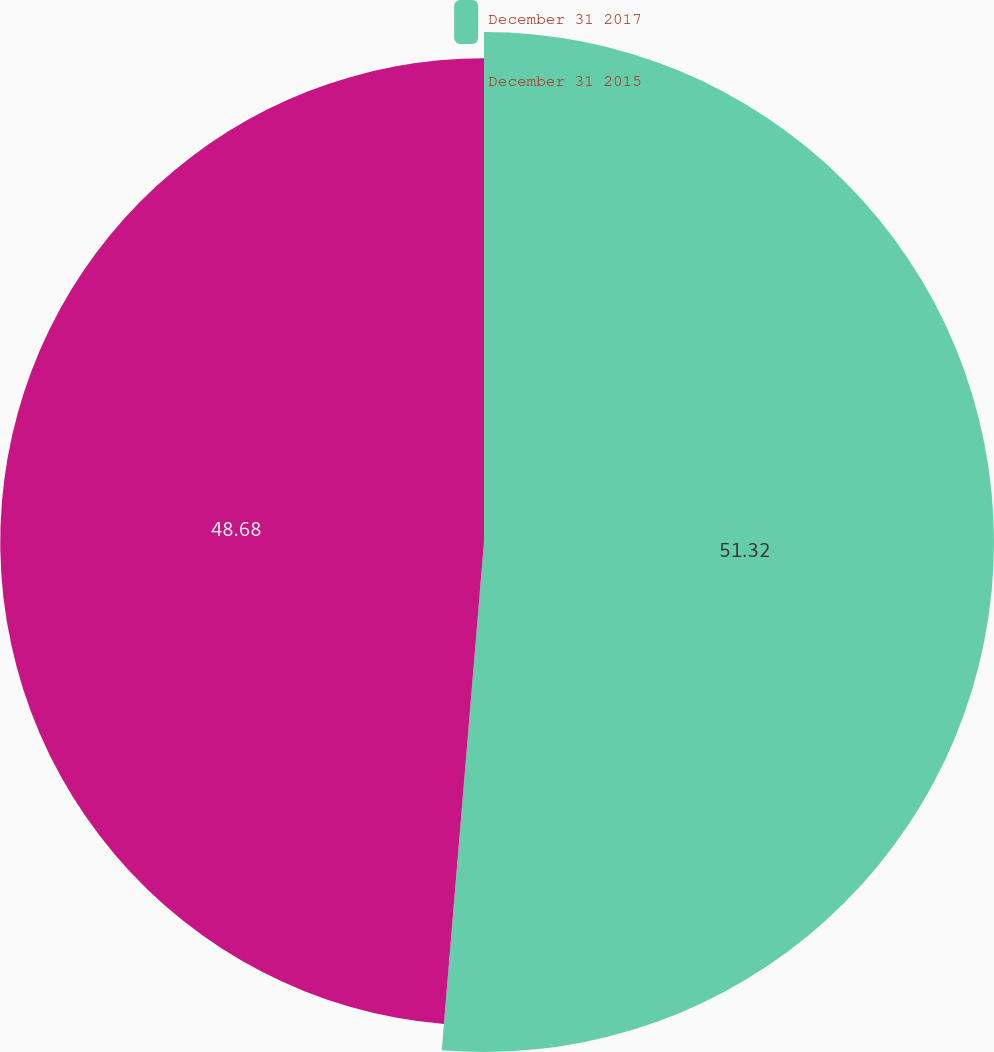Convert chart. <chart><loc_0><loc_0><loc_500><loc_500><pie_chart><fcel>December 31 2017<fcel>December 31 2015<nl><fcel>51.32%<fcel>48.68%<nl></chart> 